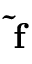Convert formula to latex. <formula><loc_0><loc_0><loc_500><loc_500>\tilde { f }</formula> 